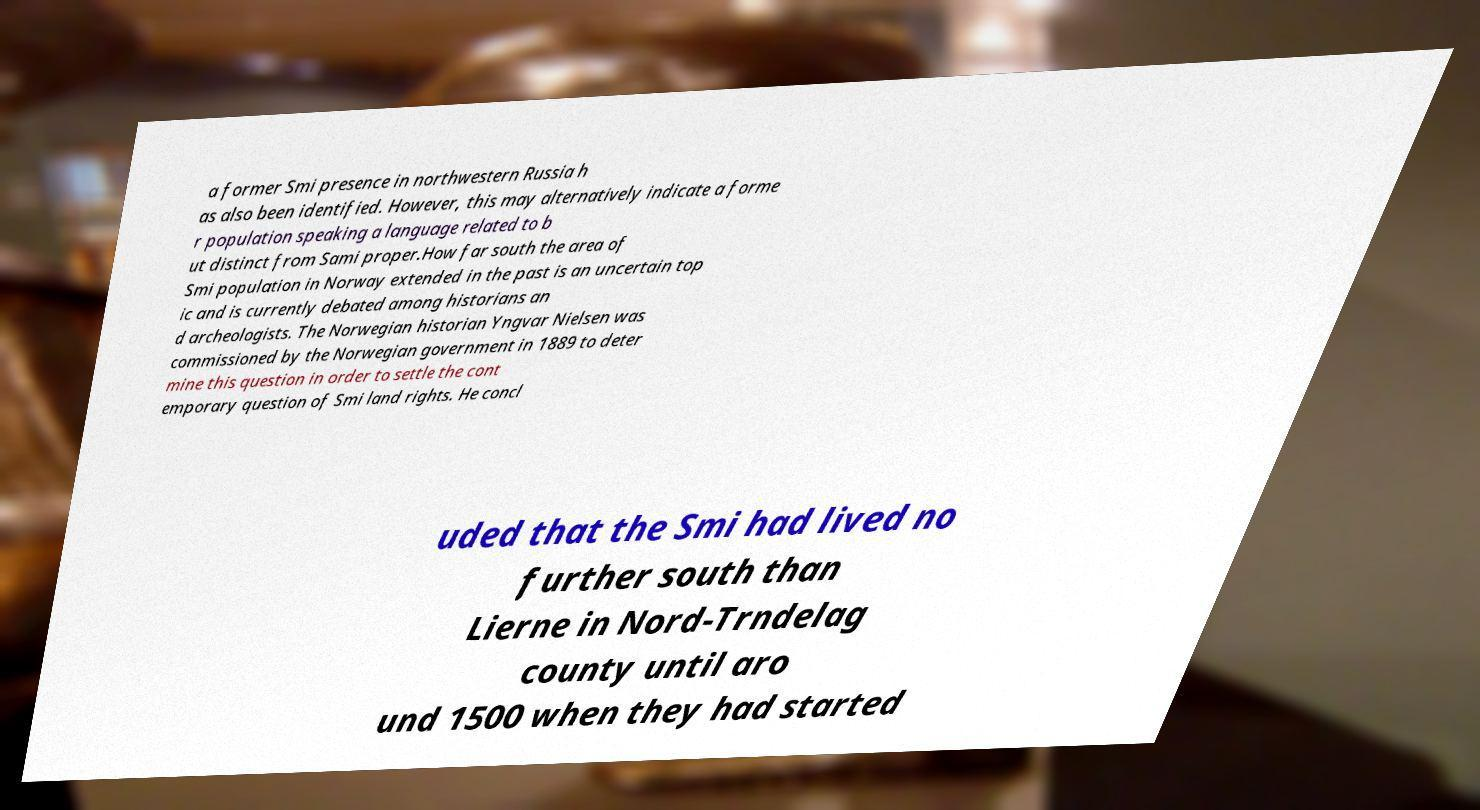Could you extract and type out the text from this image? a former Smi presence in northwestern Russia h as also been identified. However, this may alternatively indicate a forme r population speaking a language related to b ut distinct from Sami proper.How far south the area of Smi population in Norway extended in the past is an uncertain top ic and is currently debated among historians an d archeologists. The Norwegian historian Yngvar Nielsen was commissioned by the Norwegian government in 1889 to deter mine this question in order to settle the cont emporary question of Smi land rights. He concl uded that the Smi had lived no further south than Lierne in Nord-Trndelag county until aro und 1500 when they had started 